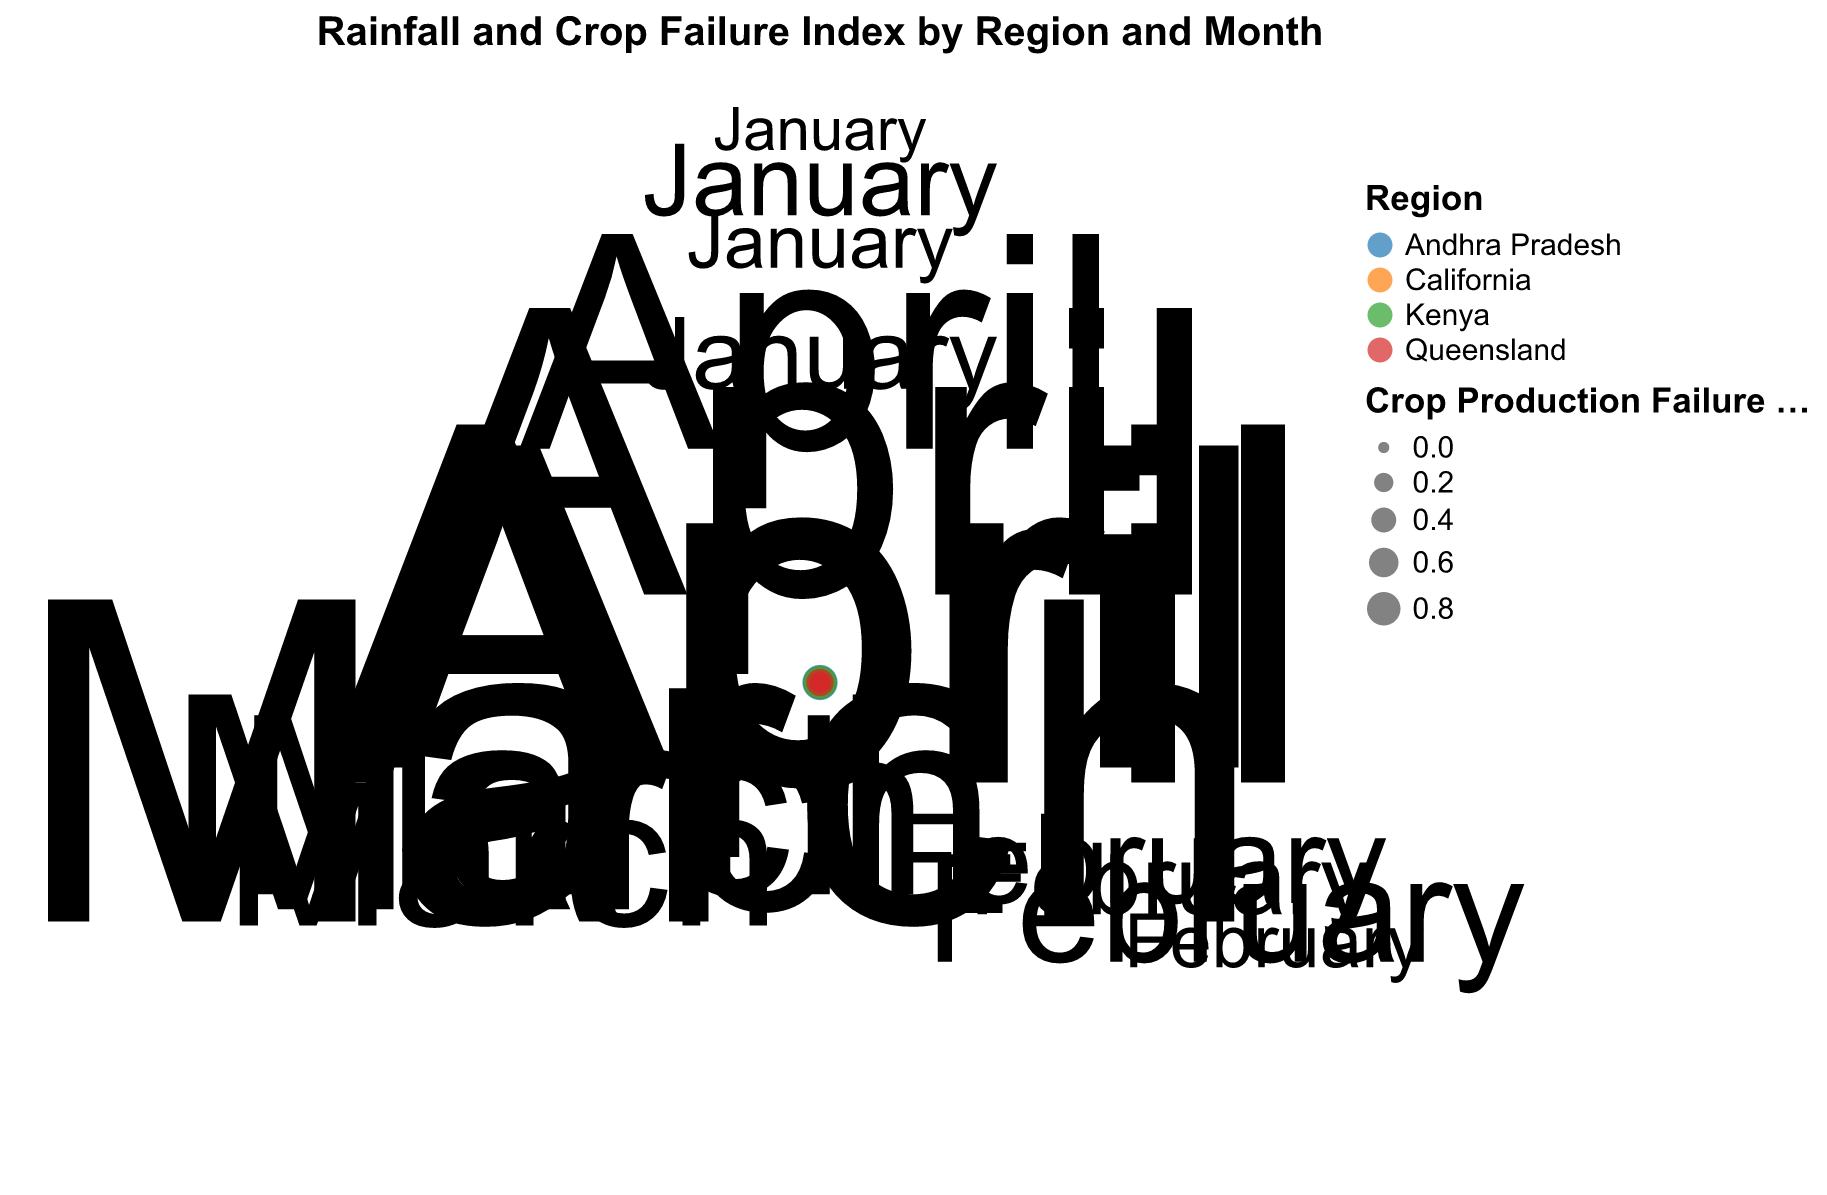What is the title of the chart? The title of the chart is centered at the top of the figure in a larger font. It reads: "Rainfall and Crop Failure Index by Region and Month".
Answer: Rainfall and Crop Failure Index by Region and Month How many regions are represented in the chart, and what are they? The chart uses different colors to represent different regions. By checking the legend, we can identify the regions: Andhra Pradesh, California, Kenya, and Queensland.
Answer: Four regions: Andhra Pradesh, California, Kenya, and Queensland Which region had the highest rainfall in January, and how much was it? Locate the data points for January and compare the radii. The largest radius in January belongs to Kenya, indicating it had the highest rainfall. The chart shows Kenya's January rainfall as 50mm.
Answer: Kenya, 50mm How does rainfall in March correlate with the Crop Production Failure Index in Andhra Pradesh? In the chart, observe Andhra Pradesh for March where the rainfall was 5mm (small radius) and the Crop Production Failure Index was 0.8 (large point size). This shows a low rainfall and high failure correlation.
Answer: Low rainfall (5mm) and high failure (0.8) Which region experienced the highest Crop Production Failure Index in April? Compare the sizes of the points in April. The largest point in this month belongs to Andhra Pradesh, indicating it had the highest failure index in April (0.9).
Answer: Andhra Pradesh, 0.9 In which months did Kenya experience zero rainfall, and what were the Crop Production Failure Indices for those months? For Kenya, look at the radii that shrink to the origin (zero rainfall). Kenya had zero rainfall in April, and the Crop Production Failure Index was 0.8.
Answer: April, 0.8 Compare the rainfall patterns between California and Queensland in February. Which region had higher rainfall, and how does their Crop Production Failure Index compare? Observe the points corresponding to February for both regions. California had 25mm rainfall and a failure index of 0.1, while Queensland had 35mm rainfall and a failure index of 0.2. Queensland had higher rainfall and a higher failure index.
Answer: Queensland had higher rainfall (35mm vs. 25mm) and a higher failure index (0.2 vs. 0.1) Which region shows the highest variation in Crop Production Failure Index across all months? Identify the range of point sizes for each region. Andhra Pradesh's points range from 0.1 to 0.9, highlighting the highest variation.
Answer: Andhra Pradesh What trend can be observed in Queensland's Crop Production Failure Index from January to April? Track the size of Queensland's points from January to April: January (0.1), February (0.2), March (0.3), and April (0.5). The trend shows a steady increase.
Answer: Steady increase Does a higher rainfall correspond with a lower Crop Production Failure Index across all regions and months? Compare radii and point sizes across the chart. Instances like Kenya in January (high rainfall, low failure) and Andhra Pradesh in April (low rainfall, high failure) support this trend. However, it's not consistent for all data points.
Answer: Generally yes, but not always consistent 